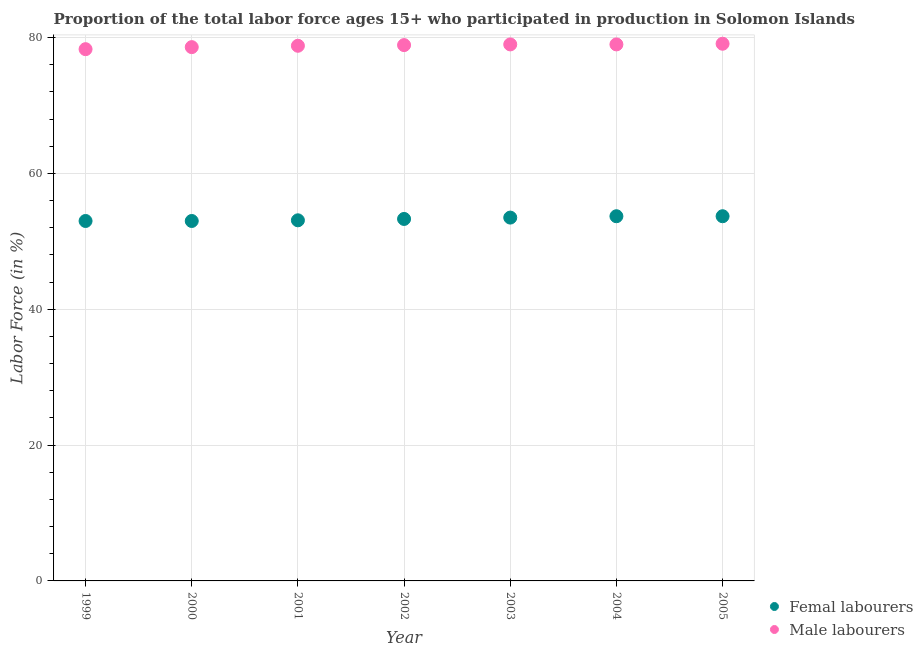How many different coloured dotlines are there?
Make the answer very short. 2. What is the percentage of female labor force in 1999?
Provide a short and direct response. 53. Across all years, what is the maximum percentage of male labour force?
Provide a short and direct response. 79.1. Across all years, what is the minimum percentage of male labour force?
Your answer should be compact. 78.3. In which year was the percentage of male labour force maximum?
Make the answer very short. 2005. What is the total percentage of female labor force in the graph?
Make the answer very short. 373.3. What is the difference between the percentage of male labour force in 1999 and that in 2002?
Give a very brief answer. -0.6. What is the difference between the percentage of male labour force in 2001 and the percentage of female labor force in 2005?
Offer a very short reply. 25.1. What is the average percentage of male labour force per year?
Ensure brevity in your answer.  78.81. In the year 2000, what is the difference between the percentage of female labor force and percentage of male labour force?
Give a very brief answer. -25.6. In how many years, is the percentage of female labor force greater than 32 %?
Provide a succinct answer. 7. What is the ratio of the percentage of male labour force in 2001 to that in 2004?
Ensure brevity in your answer.  1. Is the difference between the percentage of female labor force in 2001 and 2004 greater than the difference between the percentage of male labour force in 2001 and 2004?
Ensure brevity in your answer.  No. What is the difference between the highest and the lowest percentage of male labour force?
Your response must be concise. 0.8. How many dotlines are there?
Ensure brevity in your answer.  2. What is the difference between two consecutive major ticks on the Y-axis?
Your answer should be very brief. 20. Does the graph contain grids?
Offer a very short reply. Yes. Where does the legend appear in the graph?
Your response must be concise. Bottom right. How are the legend labels stacked?
Ensure brevity in your answer.  Vertical. What is the title of the graph?
Provide a short and direct response. Proportion of the total labor force ages 15+ who participated in production in Solomon Islands. Does "Male entrants" appear as one of the legend labels in the graph?
Make the answer very short. No. What is the label or title of the X-axis?
Your response must be concise. Year. What is the label or title of the Y-axis?
Your answer should be very brief. Labor Force (in %). What is the Labor Force (in %) of Femal labourers in 1999?
Ensure brevity in your answer.  53. What is the Labor Force (in %) of Male labourers in 1999?
Your answer should be very brief. 78.3. What is the Labor Force (in %) in Femal labourers in 2000?
Give a very brief answer. 53. What is the Labor Force (in %) in Male labourers in 2000?
Offer a terse response. 78.6. What is the Labor Force (in %) in Femal labourers in 2001?
Offer a very short reply. 53.1. What is the Labor Force (in %) of Male labourers in 2001?
Your response must be concise. 78.8. What is the Labor Force (in %) in Femal labourers in 2002?
Make the answer very short. 53.3. What is the Labor Force (in %) of Male labourers in 2002?
Your answer should be compact. 78.9. What is the Labor Force (in %) in Femal labourers in 2003?
Offer a very short reply. 53.5. What is the Labor Force (in %) in Male labourers in 2003?
Offer a very short reply. 79. What is the Labor Force (in %) in Femal labourers in 2004?
Make the answer very short. 53.7. What is the Labor Force (in %) in Male labourers in 2004?
Ensure brevity in your answer.  79. What is the Labor Force (in %) of Femal labourers in 2005?
Make the answer very short. 53.7. What is the Labor Force (in %) in Male labourers in 2005?
Make the answer very short. 79.1. Across all years, what is the maximum Labor Force (in %) of Femal labourers?
Give a very brief answer. 53.7. Across all years, what is the maximum Labor Force (in %) in Male labourers?
Offer a terse response. 79.1. Across all years, what is the minimum Labor Force (in %) of Male labourers?
Provide a succinct answer. 78.3. What is the total Labor Force (in %) in Femal labourers in the graph?
Keep it short and to the point. 373.3. What is the total Labor Force (in %) of Male labourers in the graph?
Ensure brevity in your answer.  551.7. What is the difference between the Labor Force (in %) of Male labourers in 1999 and that in 2000?
Provide a succinct answer. -0.3. What is the difference between the Labor Force (in %) of Male labourers in 1999 and that in 2002?
Keep it short and to the point. -0.6. What is the difference between the Labor Force (in %) of Femal labourers in 1999 and that in 2003?
Provide a short and direct response. -0.5. What is the difference between the Labor Force (in %) of Femal labourers in 1999 and that in 2004?
Your response must be concise. -0.7. What is the difference between the Labor Force (in %) of Male labourers in 1999 and that in 2004?
Provide a short and direct response. -0.7. What is the difference between the Labor Force (in %) of Femal labourers in 1999 and that in 2005?
Provide a short and direct response. -0.7. What is the difference between the Labor Force (in %) of Male labourers in 1999 and that in 2005?
Provide a short and direct response. -0.8. What is the difference between the Labor Force (in %) in Male labourers in 2000 and that in 2001?
Offer a terse response. -0.2. What is the difference between the Labor Force (in %) in Femal labourers in 2000 and that in 2003?
Give a very brief answer. -0.5. What is the difference between the Labor Force (in %) of Male labourers in 2000 and that in 2003?
Keep it short and to the point. -0.4. What is the difference between the Labor Force (in %) in Male labourers in 2000 and that in 2005?
Offer a very short reply. -0.5. What is the difference between the Labor Force (in %) in Male labourers in 2001 and that in 2002?
Keep it short and to the point. -0.1. What is the difference between the Labor Force (in %) of Femal labourers in 2001 and that in 2005?
Provide a succinct answer. -0.6. What is the difference between the Labor Force (in %) in Male labourers in 2001 and that in 2005?
Keep it short and to the point. -0.3. What is the difference between the Labor Force (in %) in Femal labourers in 2002 and that in 2004?
Provide a short and direct response. -0.4. What is the difference between the Labor Force (in %) of Male labourers in 2002 and that in 2004?
Make the answer very short. -0.1. What is the difference between the Labor Force (in %) of Male labourers in 2002 and that in 2005?
Provide a succinct answer. -0.2. What is the difference between the Labor Force (in %) in Femal labourers in 2003 and that in 2004?
Keep it short and to the point. -0.2. What is the difference between the Labor Force (in %) of Femal labourers in 1999 and the Labor Force (in %) of Male labourers in 2000?
Your answer should be compact. -25.6. What is the difference between the Labor Force (in %) of Femal labourers in 1999 and the Labor Force (in %) of Male labourers in 2001?
Give a very brief answer. -25.8. What is the difference between the Labor Force (in %) in Femal labourers in 1999 and the Labor Force (in %) in Male labourers in 2002?
Your answer should be compact. -25.9. What is the difference between the Labor Force (in %) in Femal labourers in 1999 and the Labor Force (in %) in Male labourers in 2003?
Provide a succinct answer. -26. What is the difference between the Labor Force (in %) in Femal labourers in 1999 and the Labor Force (in %) in Male labourers in 2004?
Offer a terse response. -26. What is the difference between the Labor Force (in %) in Femal labourers in 1999 and the Labor Force (in %) in Male labourers in 2005?
Provide a short and direct response. -26.1. What is the difference between the Labor Force (in %) in Femal labourers in 2000 and the Labor Force (in %) in Male labourers in 2001?
Offer a terse response. -25.8. What is the difference between the Labor Force (in %) in Femal labourers in 2000 and the Labor Force (in %) in Male labourers in 2002?
Offer a very short reply. -25.9. What is the difference between the Labor Force (in %) in Femal labourers in 2000 and the Labor Force (in %) in Male labourers in 2003?
Provide a succinct answer. -26. What is the difference between the Labor Force (in %) in Femal labourers in 2000 and the Labor Force (in %) in Male labourers in 2005?
Offer a very short reply. -26.1. What is the difference between the Labor Force (in %) of Femal labourers in 2001 and the Labor Force (in %) of Male labourers in 2002?
Your response must be concise. -25.8. What is the difference between the Labor Force (in %) in Femal labourers in 2001 and the Labor Force (in %) in Male labourers in 2003?
Provide a short and direct response. -25.9. What is the difference between the Labor Force (in %) of Femal labourers in 2001 and the Labor Force (in %) of Male labourers in 2004?
Offer a terse response. -25.9. What is the difference between the Labor Force (in %) in Femal labourers in 2002 and the Labor Force (in %) in Male labourers in 2003?
Your answer should be very brief. -25.7. What is the difference between the Labor Force (in %) in Femal labourers in 2002 and the Labor Force (in %) in Male labourers in 2004?
Offer a terse response. -25.7. What is the difference between the Labor Force (in %) of Femal labourers in 2002 and the Labor Force (in %) of Male labourers in 2005?
Your answer should be compact. -25.8. What is the difference between the Labor Force (in %) in Femal labourers in 2003 and the Labor Force (in %) in Male labourers in 2004?
Offer a terse response. -25.5. What is the difference between the Labor Force (in %) of Femal labourers in 2003 and the Labor Force (in %) of Male labourers in 2005?
Make the answer very short. -25.6. What is the difference between the Labor Force (in %) of Femal labourers in 2004 and the Labor Force (in %) of Male labourers in 2005?
Offer a terse response. -25.4. What is the average Labor Force (in %) of Femal labourers per year?
Make the answer very short. 53.33. What is the average Labor Force (in %) in Male labourers per year?
Give a very brief answer. 78.81. In the year 1999, what is the difference between the Labor Force (in %) of Femal labourers and Labor Force (in %) of Male labourers?
Keep it short and to the point. -25.3. In the year 2000, what is the difference between the Labor Force (in %) in Femal labourers and Labor Force (in %) in Male labourers?
Give a very brief answer. -25.6. In the year 2001, what is the difference between the Labor Force (in %) in Femal labourers and Labor Force (in %) in Male labourers?
Your response must be concise. -25.7. In the year 2002, what is the difference between the Labor Force (in %) in Femal labourers and Labor Force (in %) in Male labourers?
Make the answer very short. -25.6. In the year 2003, what is the difference between the Labor Force (in %) in Femal labourers and Labor Force (in %) in Male labourers?
Ensure brevity in your answer.  -25.5. In the year 2004, what is the difference between the Labor Force (in %) of Femal labourers and Labor Force (in %) of Male labourers?
Provide a succinct answer. -25.3. In the year 2005, what is the difference between the Labor Force (in %) of Femal labourers and Labor Force (in %) of Male labourers?
Your answer should be very brief. -25.4. What is the ratio of the Labor Force (in %) in Femal labourers in 1999 to that in 2000?
Your answer should be compact. 1. What is the ratio of the Labor Force (in %) of Femal labourers in 1999 to that in 2002?
Offer a terse response. 0.99. What is the ratio of the Labor Force (in %) in Femal labourers in 1999 to that in 2003?
Offer a very short reply. 0.99. What is the ratio of the Labor Force (in %) of Male labourers in 1999 to that in 2003?
Offer a very short reply. 0.99. What is the ratio of the Labor Force (in %) of Femal labourers in 1999 to that in 2004?
Give a very brief answer. 0.99. What is the ratio of the Labor Force (in %) in Male labourers in 1999 to that in 2004?
Provide a succinct answer. 0.99. What is the ratio of the Labor Force (in %) in Male labourers in 2000 to that in 2002?
Provide a succinct answer. 1. What is the ratio of the Labor Force (in %) in Femal labourers in 2000 to that in 2005?
Provide a short and direct response. 0.99. What is the ratio of the Labor Force (in %) of Male labourers in 2000 to that in 2005?
Keep it short and to the point. 0.99. What is the ratio of the Labor Force (in %) of Femal labourers in 2001 to that in 2002?
Ensure brevity in your answer.  1. What is the ratio of the Labor Force (in %) in Male labourers in 2001 to that in 2002?
Your response must be concise. 1. What is the ratio of the Labor Force (in %) in Femal labourers in 2001 to that in 2003?
Provide a short and direct response. 0.99. What is the ratio of the Labor Force (in %) in Male labourers in 2001 to that in 2004?
Keep it short and to the point. 1. What is the ratio of the Labor Force (in %) in Male labourers in 2001 to that in 2005?
Provide a succinct answer. 1. What is the ratio of the Labor Force (in %) in Femal labourers in 2002 to that in 2003?
Offer a terse response. 1. What is the ratio of the Labor Force (in %) in Male labourers in 2002 to that in 2004?
Your answer should be compact. 1. What is the ratio of the Labor Force (in %) in Male labourers in 2002 to that in 2005?
Offer a terse response. 1. What is the ratio of the Labor Force (in %) of Femal labourers in 2003 to that in 2004?
Your answer should be compact. 1. What is the ratio of the Labor Force (in %) of Femal labourers in 2003 to that in 2005?
Offer a terse response. 1. What is the ratio of the Labor Force (in %) of Femal labourers in 2004 to that in 2005?
Ensure brevity in your answer.  1. What is the ratio of the Labor Force (in %) in Male labourers in 2004 to that in 2005?
Keep it short and to the point. 1. What is the difference between the highest and the lowest Labor Force (in %) in Femal labourers?
Ensure brevity in your answer.  0.7. What is the difference between the highest and the lowest Labor Force (in %) in Male labourers?
Your answer should be compact. 0.8. 